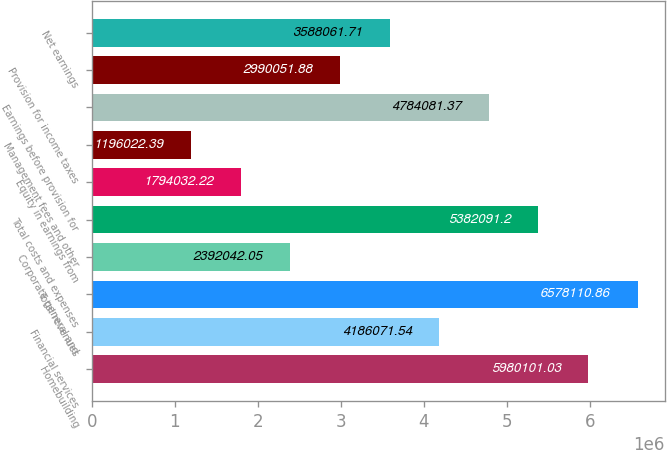<chart> <loc_0><loc_0><loc_500><loc_500><bar_chart><fcel>Homebuilding<fcel>Financial services<fcel>Total revenues<fcel>Corporate general and<fcel>Total costs and expenses<fcel>Equity in earnings from<fcel>Management fees and other<fcel>Earnings before provision for<fcel>Provision for income taxes<fcel>Net earnings<nl><fcel>5.9801e+06<fcel>4.18607e+06<fcel>6.57811e+06<fcel>2.39204e+06<fcel>5.38209e+06<fcel>1.79403e+06<fcel>1.19602e+06<fcel>4.78408e+06<fcel>2.99005e+06<fcel>3.58806e+06<nl></chart> 